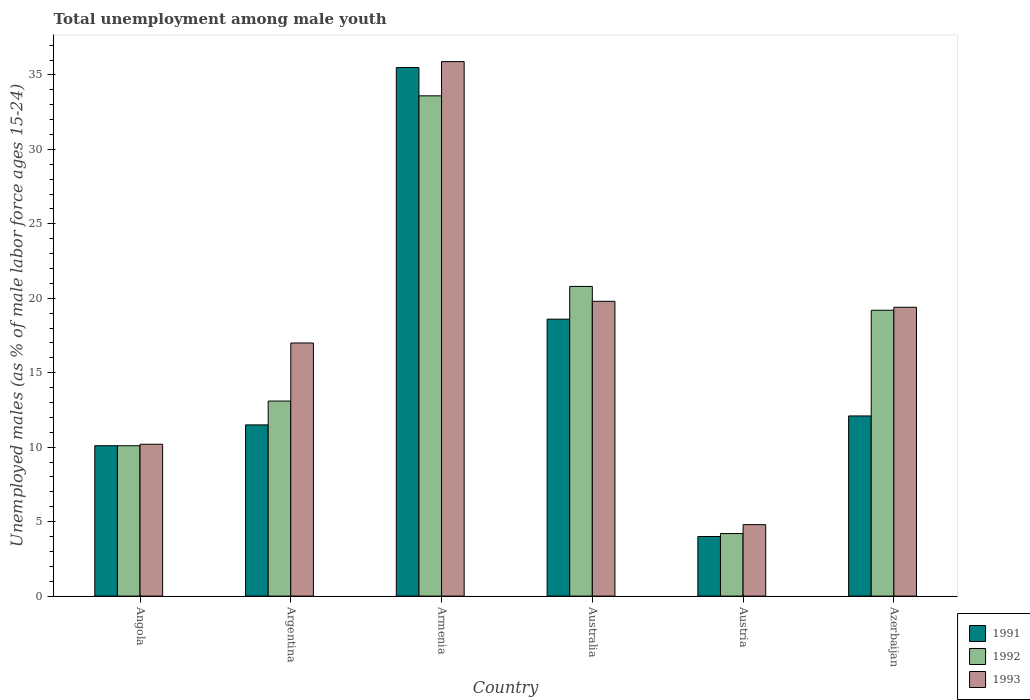How many groups of bars are there?
Offer a terse response. 6. How many bars are there on the 4th tick from the left?
Ensure brevity in your answer.  3. How many bars are there on the 1st tick from the right?
Make the answer very short. 3. In how many cases, is the number of bars for a given country not equal to the number of legend labels?
Keep it short and to the point. 0. What is the percentage of unemployed males in in 1992 in Azerbaijan?
Your response must be concise. 19.2. Across all countries, what is the maximum percentage of unemployed males in in 1992?
Make the answer very short. 33.6. Across all countries, what is the minimum percentage of unemployed males in in 1992?
Provide a succinct answer. 4.2. In which country was the percentage of unemployed males in in 1991 maximum?
Offer a very short reply. Armenia. What is the total percentage of unemployed males in in 1991 in the graph?
Make the answer very short. 91.8. What is the difference between the percentage of unemployed males in in 1993 in Angola and that in Argentina?
Your response must be concise. -6.8. What is the difference between the percentage of unemployed males in in 1993 in Austria and the percentage of unemployed males in in 1991 in Azerbaijan?
Offer a terse response. -7.3. What is the average percentage of unemployed males in in 1993 per country?
Your answer should be compact. 17.85. What is the difference between the percentage of unemployed males in of/in 1991 and percentage of unemployed males in of/in 1993 in Azerbaijan?
Your answer should be very brief. -7.3. In how many countries, is the percentage of unemployed males in in 1993 greater than 30 %?
Your response must be concise. 1. What is the ratio of the percentage of unemployed males in in 1993 in Armenia to that in Australia?
Keep it short and to the point. 1.81. Is the percentage of unemployed males in in 1991 in Angola less than that in Argentina?
Ensure brevity in your answer.  Yes. Is the difference between the percentage of unemployed males in in 1991 in Australia and Austria greater than the difference between the percentage of unemployed males in in 1993 in Australia and Austria?
Keep it short and to the point. No. What is the difference between the highest and the second highest percentage of unemployed males in in 1992?
Your answer should be very brief. 14.4. What is the difference between the highest and the lowest percentage of unemployed males in in 1991?
Your answer should be compact. 31.5. Is the sum of the percentage of unemployed males in in 1991 in Angola and Austria greater than the maximum percentage of unemployed males in in 1992 across all countries?
Give a very brief answer. No. What does the 1st bar from the left in Argentina represents?
Keep it short and to the point. 1991. What does the 3rd bar from the right in Australia represents?
Offer a very short reply. 1991. Is it the case that in every country, the sum of the percentage of unemployed males in in 1993 and percentage of unemployed males in in 1992 is greater than the percentage of unemployed males in in 1991?
Your response must be concise. Yes. What is the difference between two consecutive major ticks on the Y-axis?
Make the answer very short. 5. Are the values on the major ticks of Y-axis written in scientific E-notation?
Offer a terse response. No. Does the graph contain any zero values?
Provide a short and direct response. No. Where does the legend appear in the graph?
Give a very brief answer. Bottom right. How many legend labels are there?
Keep it short and to the point. 3. How are the legend labels stacked?
Provide a short and direct response. Vertical. What is the title of the graph?
Provide a succinct answer. Total unemployment among male youth. Does "1981" appear as one of the legend labels in the graph?
Your answer should be very brief. No. What is the label or title of the X-axis?
Offer a terse response. Country. What is the label or title of the Y-axis?
Give a very brief answer. Unemployed males (as % of male labor force ages 15-24). What is the Unemployed males (as % of male labor force ages 15-24) of 1991 in Angola?
Keep it short and to the point. 10.1. What is the Unemployed males (as % of male labor force ages 15-24) of 1992 in Angola?
Ensure brevity in your answer.  10.1. What is the Unemployed males (as % of male labor force ages 15-24) of 1993 in Angola?
Provide a short and direct response. 10.2. What is the Unemployed males (as % of male labor force ages 15-24) of 1991 in Argentina?
Ensure brevity in your answer.  11.5. What is the Unemployed males (as % of male labor force ages 15-24) of 1992 in Argentina?
Keep it short and to the point. 13.1. What is the Unemployed males (as % of male labor force ages 15-24) of 1991 in Armenia?
Offer a terse response. 35.5. What is the Unemployed males (as % of male labor force ages 15-24) of 1992 in Armenia?
Keep it short and to the point. 33.6. What is the Unemployed males (as % of male labor force ages 15-24) of 1993 in Armenia?
Keep it short and to the point. 35.9. What is the Unemployed males (as % of male labor force ages 15-24) in 1991 in Australia?
Make the answer very short. 18.6. What is the Unemployed males (as % of male labor force ages 15-24) of 1992 in Australia?
Your answer should be compact. 20.8. What is the Unemployed males (as % of male labor force ages 15-24) of 1993 in Australia?
Your response must be concise. 19.8. What is the Unemployed males (as % of male labor force ages 15-24) of 1992 in Austria?
Make the answer very short. 4.2. What is the Unemployed males (as % of male labor force ages 15-24) of 1993 in Austria?
Your answer should be compact. 4.8. What is the Unemployed males (as % of male labor force ages 15-24) in 1991 in Azerbaijan?
Your response must be concise. 12.1. What is the Unemployed males (as % of male labor force ages 15-24) of 1992 in Azerbaijan?
Keep it short and to the point. 19.2. What is the Unemployed males (as % of male labor force ages 15-24) of 1993 in Azerbaijan?
Make the answer very short. 19.4. Across all countries, what is the maximum Unemployed males (as % of male labor force ages 15-24) of 1991?
Offer a terse response. 35.5. Across all countries, what is the maximum Unemployed males (as % of male labor force ages 15-24) in 1992?
Give a very brief answer. 33.6. Across all countries, what is the maximum Unemployed males (as % of male labor force ages 15-24) of 1993?
Keep it short and to the point. 35.9. Across all countries, what is the minimum Unemployed males (as % of male labor force ages 15-24) of 1992?
Provide a succinct answer. 4.2. Across all countries, what is the minimum Unemployed males (as % of male labor force ages 15-24) in 1993?
Ensure brevity in your answer.  4.8. What is the total Unemployed males (as % of male labor force ages 15-24) in 1991 in the graph?
Give a very brief answer. 91.8. What is the total Unemployed males (as % of male labor force ages 15-24) of 1992 in the graph?
Offer a terse response. 101. What is the total Unemployed males (as % of male labor force ages 15-24) in 1993 in the graph?
Provide a short and direct response. 107.1. What is the difference between the Unemployed males (as % of male labor force ages 15-24) in 1991 in Angola and that in Armenia?
Offer a terse response. -25.4. What is the difference between the Unemployed males (as % of male labor force ages 15-24) in 1992 in Angola and that in Armenia?
Make the answer very short. -23.5. What is the difference between the Unemployed males (as % of male labor force ages 15-24) in 1993 in Angola and that in Armenia?
Ensure brevity in your answer.  -25.7. What is the difference between the Unemployed males (as % of male labor force ages 15-24) in 1991 in Angola and that in Australia?
Ensure brevity in your answer.  -8.5. What is the difference between the Unemployed males (as % of male labor force ages 15-24) of 1992 in Angola and that in Australia?
Give a very brief answer. -10.7. What is the difference between the Unemployed males (as % of male labor force ages 15-24) of 1993 in Angola and that in Australia?
Offer a terse response. -9.6. What is the difference between the Unemployed males (as % of male labor force ages 15-24) in 1991 in Angola and that in Austria?
Ensure brevity in your answer.  6.1. What is the difference between the Unemployed males (as % of male labor force ages 15-24) in 1992 in Angola and that in Azerbaijan?
Give a very brief answer. -9.1. What is the difference between the Unemployed males (as % of male labor force ages 15-24) of 1991 in Argentina and that in Armenia?
Keep it short and to the point. -24. What is the difference between the Unemployed males (as % of male labor force ages 15-24) of 1992 in Argentina and that in Armenia?
Keep it short and to the point. -20.5. What is the difference between the Unemployed males (as % of male labor force ages 15-24) of 1993 in Argentina and that in Armenia?
Ensure brevity in your answer.  -18.9. What is the difference between the Unemployed males (as % of male labor force ages 15-24) of 1991 in Argentina and that in Australia?
Make the answer very short. -7.1. What is the difference between the Unemployed males (as % of male labor force ages 15-24) of 1993 in Argentina and that in Australia?
Your answer should be very brief. -2.8. What is the difference between the Unemployed males (as % of male labor force ages 15-24) in 1991 in Argentina and that in Austria?
Give a very brief answer. 7.5. What is the difference between the Unemployed males (as % of male labor force ages 15-24) of 1992 in Argentina and that in Austria?
Ensure brevity in your answer.  8.9. What is the difference between the Unemployed males (as % of male labor force ages 15-24) of 1993 in Argentina and that in Austria?
Provide a succinct answer. 12.2. What is the difference between the Unemployed males (as % of male labor force ages 15-24) of 1993 in Argentina and that in Azerbaijan?
Give a very brief answer. -2.4. What is the difference between the Unemployed males (as % of male labor force ages 15-24) in 1991 in Armenia and that in Australia?
Your answer should be compact. 16.9. What is the difference between the Unemployed males (as % of male labor force ages 15-24) of 1992 in Armenia and that in Australia?
Your answer should be compact. 12.8. What is the difference between the Unemployed males (as % of male labor force ages 15-24) in 1993 in Armenia and that in Australia?
Provide a succinct answer. 16.1. What is the difference between the Unemployed males (as % of male labor force ages 15-24) in 1991 in Armenia and that in Austria?
Provide a succinct answer. 31.5. What is the difference between the Unemployed males (as % of male labor force ages 15-24) of 1992 in Armenia and that in Austria?
Offer a very short reply. 29.4. What is the difference between the Unemployed males (as % of male labor force ages 15-24) in 1993 in Armenia and that in Austria?
Give a very brief answer. 31.1. What is the difference between the Unemployed males (as % of male labor force ages 15-24) in 1991 in Armenia and that in Azerbaijan?
Make the answer very short. 23.4. What is the difference between the Unemployed males (as % of male labor force ages 15-24) in 1992 in Armenia and that in Azerbaijan?
Your response must be concise. 14.4. What is the difference between the Unemployed males (as % of male labor force ages 15-24) in 1991 in Australia and that in Austria?
Keep it short and to the point. 14.6. What is the difference between the Unemployed males (as % of male labor force ages 15-24) in 1992 in Australia and that in Austria?
Your answer should be compact. 16.6. What is the difference between the Unemployed males (as % of male labor force ages 15-24) of 1993 in Australia and that in Austria?
Provide a short and direct response. 15. What is the difference between the Unemployed males (as % of male labor force ages 15-24) in 1991 in Australia and that in Azerbaijan?
Make the answer very short. 6.5. What is the difference between the Unemployed males (as % of male labor force ages 15-24) in 1992 in Australia and that in Azerbaijan?
Offer a very short reply. 1.6. What is the difference between the Unemployed males (as % of male labor force ages 15-24) in 1993 in Austria and that in Azerbaijan?
Your answer should be very brief. -14.6. What is the difference between the Unemployed males (as % of male labor force ages 15-24) in 1991 in Angola and the Unemployed males (as % of male labor force ages 15-24) in 1992 in Argentina?
Keep it short and to the point. -3. What is the difference between the Unemployed males (as % of male labor force ages 15-24) in 1991 in Angola and the Unemployed males (as % of male labor force ages 15-24) in 1993 in Argentina?
Offer a terse response. -6.9. What is the difference between the Unemployed males (as % of male labor force ages 15-24) of 1991 in Angola and the Unemployed males (as % of male labor force ages 15-24) of 1992 in Armenia?
Your answer should be compact. -23.5. What is the difference between the Unemployed males (as % of male labor force ages 15-24) of 1991 in Angola and the Unemployed males (as % of male labor force ages 15-24) of 1993 in Armenia?
Your answer should be very brief. -25.8. What is the difference between the Unemployed males (as % of male labor force ages 15-24) of 1992 in Angola and the Unemployed males (as % of male labor force ages 15-24) of 1993 in Armenia?
Make the answer very short. -25.8. What is the difference between the Unemployed males (as % of male labor force ages 15-24) of 1991 in Angola and the Unemployed males (as % of male labor force ages 15-24) of 1992 in Australia?
Your answer should be very brief. -10.7. What is the difference between the Unemployed males (as % of male labor force ages 15-24) in 1992 in Angola and the Unemployed males (as % of male labor force ages 15-24) in 1993 in Australia?
Ensure brevity in your answer.  -9.7. What is the difference between the Unemployed males (as % of male labor force ages 15-24) of 1991 in Angola and the Unemployed males (as % of male labor force ages 15-24) of 1993 in Austria?
Make the answer very short. 5.3. What is the difference between the Unemployed males (as % of male labor force ages 15-24) of 1992 in Angola and the Unemployed males (as % of male labor force ages 15-24) of 1993 in Austria?
Your answer should be compact. 5.3. What is the difference between the Unemployed males (as % of male labor force ages 15-24) of 1992 in Angola and the Unemployed males (as % of male labor force ages 15-24) of 1993 in Azerbaijan?
Offer a very short reply. -9.3. What is the difference between the Unemployed males (as % of male labor force ages 15-24) of 1991 in Argentina and the Unemployed males (as % of male labor force ages 15-24) of 1992 in Armenia?
Provide a short and direct response. -22.1. What is the difference between the Unemployed males (as % of male labor force ages 15-24) in 1991 in Argentina and the Unemployed males (as % of male labor force ages 15-24) in 1993 in Armenia?
Provide a succinct answer. -24.4. What is the difference between the Unemployed males (as % of male labor force ages 15-24) of 1992 in Argentina and the Unemployed males (as % of male labor force ages 15-24) of 1993 in Armenia?
Ensure brevity in your answer.  -22.8. What is the difference between the Unemployed males (as % of male labor force ages 15-24) in 1992 in Argentina and the Unemployed males (as % of male labor force ages 15-24) in 1993 in Australia?
Keep it short and to the point. -6.7. What is the difference between the Unemployed males (as % of male labor force ages 15-24) of 1991 in Argentina and the Unemployed males (as % of male labor force ages 15-24) of 1992 in Azerbaijan?
Keep it short and to the point. -7.7. What is the difference between the Unemployed males (as % of male labor force ages 15-24) in 1991 in Armenia and the Unemployed males (as % of male labor force ages 15-24) in 1992 in Australia?
Your answer should be compact. 14.7. What is the difference between the Unemployed males (as % of male labor force ages 15-24) in 1991 in Armenia and the Unemployed males (as % of male labor force ages 15-24) in 1993 in Australia?
Your answer should be compact. 15.7. What is the difference between the Unemployed males (as % of male labor force ages 15-24) in 1992 in Armenia and the Unemployed males (as % of male labor force ages 15-24) in 1993 in Australia?
Offer a terse response. 13.8. What is the difference between the Unemployed males (as % of male labor force ages 15-24) of 1991 in Armenia and the Unemployed males (as % of male labor force ages 15-24) of 1992 in Austria?
Offer a very short reply. 31.3. What is the difference between the Unemployed males (as % of male labor force ages 15-24) in 1991 in Armenia and the Unemployed males (as % of male labor force ages 15-24) in 1993 in Austria?
Provide a succinct answer. 30.7. What is the difference between the Unemployed males (as % of male labor force ages 15-24) of 1992 in Armenia and the Unemployed males (as % of male labor force ages 15-24) of 1993 in Austria?
Your answer should be very brief. 28.8. What is the difference between the Unemployed males (as % of male labor force ages 15-24) of 1991 in Armenia and the Unemployed males (as % of male labor force ages 15-24) of 1993 in Azerbaijan?
Your answer should be very brief. 16.1. What is the difference between the Unemployed males (as % of male labor force ages 15-24) of 1992 in Armenia and the Unemployed males (as % of male labor force ages 15-24) of 1993 in Azerbaijan?
Ensure brevity in your answer.  14.2. What is the difference between the Unemployed males (as % of male labor force ages 15-24) in 1991 in Australia and the Unemployed males (as % of male labor force ages 15-24) in 1992 in Austria?
Your response must be concise. 14.4. What is the difference between the Unemployed males (as % of male labor force ages 15-24) of 1991 in Australia and the Unemployed males (as % of male labor force ages 15-24) of 1993 in Austria?
Your response must be concise. 13.8. What is the difference between the Unemployed males (as % of male labor force ages 15-24) of 1991 in Australia and the Unemployed males (as % of male labor force ages 15-24) of 1992 in Azerbaijan?
Make the answer very short. -0.6. What is the difference between the Unemployed males (as % of male labor force ages 15-24) in 1992 in Australia and the Unemployed males (as % of male labor force ages 15-24) in 1993 in Azerbaijan?
Provide a short and direct response. 1.4. What is the difference between the Unemployed males (as % of male labor force ages 15-24) in 1991 in Austria and the Unemployed males (as % of male labor force ages 15-24) in 1992 in Azerbaijan?
Your response must be concise. -15.2. What is the difference between the Unemployed males (as % of male labor force ages 15-24) of 1991 in Austria and the Unemployed males (as % of male labor force ages 15-24) of 1993 in Azerbaijan?
Ensure brevity in your answer.  -15.4. What is the difference between the Unemployed males (as % of male labor force ages 15-24) in 1992 in Austria and the Unemployed males (as % of male labor force ages 15-24) in 1993 in Azerbaijan?
Give a very brief answer. -15.2. What is the average Unemployed males (as % of male labor force ages 15-24) in 1991 per country?
Offer a very short reply. 15.3. What is the average Unemployed males (as % of male labor force ages 15-24) of 1992 per country?
Offer a terse response. 16.83. What is the average Unemployed males (as % of male labor force ages 15-24) in 1993 per country?
Offer a very short reply. 17.85. What is the difference between the Unemployed males (as % of male labor force ages 15-24) of 1991 and Unemployed males (as % of male labor force ages 15-24) of 1992 in Angola?
Your answer should be compact. 0. What is the difference between the Unemployed males (as % of male labor force ages 15-24) of 1992 and Unemployed males (as % of male labor force ages 15-24) of 1993 in Angola?
Your answer should be compact. -0.1. What is the difference between the Unemployed males (as % of male labor force ages 15-24) of 1991 and Unemployed males (as % of male labor force ages 15-24) of 1992 in Argentina?
Your answer should be compact. -1.6. What is the difference between the Unemployed males (as % of male labor force ages 15-24) of 1992 and Unemployed males (as % of male labor force ages 15-24) of 1993 in Argentina?
Your answer should be very brief. -3.9. What is the difference between the Unemployed males (as % of male labor force ages 15-24) of 1991 and Unemployed males (as % of male labor force ages 15-24) of 1992 in Armenia?
Keep it short and to the point. 1.9. What is the difference between the Unemployed males (as % of male labor force ages 15-24) of 1991 and Unemployed males (as % of male labor force ages 15-24) of 1993 in Armenia?
Keep it short and to the point. -0.4. What is the difference between the Unemployed males (as % of male labor force ages 15-24) in 1992 and Unemployed males (as % of male labor force ages 15-24) in 1993 in Australia?
Provide a short and direct response. 1. What is the difference between the Unemployed males (as % of male labor force ages 15-24) of 1991 and Unemployed males (as % of male labor force ages 15-24) of 1992 in Austria?
Make the answer very short. -0.2. What is the difference between the Unemployed males (as % of male labor force ages 15-24) in 1991 and Unemployed males (as % of male labor force ages 15-24) in 1993 in Austria?
Ensure brevity in your answer.  -0.8. What is the difference between the Unemployed males (as % of male labor force ages 15-24) of 1992 and Unemployed males (as % of male labor force ages 15-24) of 1993 in Azerbaijan?
Your answer should be compact. -0.2. What is the ratio of the Unemployed males (as % of male labor force ages 15-24) of 1991 in Angola to that in Argentina?
Your answer should be compact. 0.88. What is the ratio of the Unemployed males (as % of male labor force ages 15-24) in 1992 in Angola to that in Argentina?
Give a very brief answer. 0.77. What is the ratio of the Unemployed males (as % of male labor force ages 15-24) in 1991 in Angola to that in Armenia?
Your response must be concise. 0.28. What is the ratio of the Unemployed males (as % of male labor force ages 15-24) in 1992 in Angola to that in Armenia?
Your response must be concise. 0.3. What is the ratio of the Unemployed males (as % of male labor force ages 15-24) of 1993 in Angola to that in Armenia?
Make the answer very short. 0.28. What is the ratio of the Unemployed males (as % of male labor force ages 15-24) in 1991 in Angola to that in Australia?
Give a very brief answer. 0.54. What is the ratio of the Unemployed males (as % of male labor force ages 15-24) of 1992 in Angola to that in Australia?
Your response must be concise. 0.49. What is the ratio of the Unemployed males (as % of male labor force ages 15-24) in 1993 in Angola to that in Australia?
Ensure brevity in your answer.  0.52. What is the ratio of the Unemployed males (as % of male labor force ages 15-24) in 1991 in Angola to that in Austria?
Give a very brief answer. 2.52. What is the ratio of the Unemployed males (as % of male labor force ages 15-24) of 1992 in Angola to that in Austria?
Offer a very short reply. 2.4. What is the ratio of the Unemployed males (as % of male labor force ages 15-24) of 1993 in Angola to that in Austria?
Your response must be concise. 2.12. What is the ratio of the Unemployed males (as % of male labor force ages 15-24) in 1991 in Angola to that in Azerbaijan?
Your answer should be very brief. 0.83. What is the ratio of the Unemployed males (as % of male labor force ages 15-24) of 1992 in Angola to that in Azerbaijan?
Offer a very short reply. 0.53. What is the ratio of the Unemployed males (as % of male labor force ages 15-24) in 1993 in Angola to that in Azerbaijan?
Ensure brevity in your answer.  0.53. What is the ratio of the Unemployed males (as % of male labor force ages 15-24) in 1991 in Argentina to that in Armenia?
Make the answer very short. 0.32. What is the ratio of the Unemployed males (as % of male labor force ages 15-24) of 1992 in Argentina to that in Armenia?
Make the answer very short. 0.39. What is the ratio of the Unemployed males (as % of male labor force ages 15-24) of 1993 in Argentina to that in Armenia?
Ensure brevity in your answer.  0.47. What is the ratio of the Unemployed males (as % of male labor force ages 15-24) of 1991 in Argentina to that in Australia?
Your response must be concise. 0.62. What is the ratio of the Unemployed males (as % of male labor force ages 15-24) in 1992 in Argentina to that in Australia?
Keep it short and to the point. 0.63. What is the ratio of the Unemployed males (as % of male labor force ages 15-24) of 1993 in Argentina to that in Australia?
Provide a short and direct response. 0.86. What is the ratio of the Unemployed males (as % of male labor force ages 15-24) in 1991 in Argentina to that in Austria?
Provide a short and direct response. 2.88. What is the ratio of the Unemployed males (as % of male labor force ages 15-24) in 1992 in Argentina to that in Austria?
Your answer should be very brief. 3.12. What is the ratio of the Unemployed males (as % of male labor force ages 15-24) in 1993 in Argentina to that in Austria?
Offer a very short reply. 3.54. What is the ratio of the Unemployed males (as % of male labor force ages 15-24) of 1991 in Argentina to that in Azerbaijan?
Your response must be concise. 0.95. What is the ratio of the Unemployed males (as % of male labor force ages 15-24) in 1992 in Argentina to that in Azerbaijan?
Provide a succinct answer. 0.68. What is the ratio of the Unemployed males (as % of male labor force ages 15-24) of 1993 in Argentina to that in Azerbaijan?
Offer a very short reply. 0.88. What is the ratio of the Unemployed males (as % of male labor force ages 15-24) in 1991 in Armenia to that in Australia?
Your answer should be very brief. 1.91. What is the ratio of the Unemployed males (as % of male labor force ages 15-24) of 1992 in Armenia to that in Australia?
Your response must be concise. 1.62. What is the ratio of the Unemployed males (as % of male labor force ages 15-24) of 1993 in Armenia to that in Australia?
Your response must be concise. 1.81. What is the ratio of the Unemployed males (as % of male labor force ages 15-24) of 1991 in Armenia to that in Austria?
Keep it short and to the point. 8.88. What is the ratio of the Unemployed males (as % of male labor force ages 15-24) in 1992 in Armenia to that in Austria?
Provide a short and direct response. 8. What is the ratio of the Unemployed males (as % of male labor force ages 15-24) of 1993 in Armenia to that in Austria?
Your answer should be very brief. 7.48. What is the ratio of the Unemployed males (as % of male labor force ages 15-24) of 1991 in Armenia to that in Azerbaijan?
Provide a succinct answer. 2.93. What is the ratio of the Unemployed males (as % of male labor force ages 15-24) in 1992 in Armenia to that in Azerbaijan?
Make the answer very short. 1.75. What is the ratio of the Unemployed males (as % of male labor force ages 15-24) of 1993 in Armenia to that in Azerbaijan?
Offer a terse response. 1.85. What is the ratio of the Unemployed males (as % of male labor force ages 15-24) of 1991 in Australia to that in Austria?
Keep it short and to the point. 4.65. What is the ratio of the Unemployed males (as % of male labor force ages 15-24) of 1992 in Australia to that in Austria?
Ensure brevity in your answer.  4.95. What is the ratio of the Unemployed males (as % of male labor force ages 15-24) in 1993 in Australia to that in Austria?
Provide a succinct answer. 4.12. What is the ratio of the Unemployed males (as % of male labor force ages 15-24) in 1991 in Australia to that in Azerbaijan?
Offer a very short reply. 1.54. What is the ratio of the Unemployed males (as % of male labor force ages 15-24) of 1993 in Australia to that in Azerbaijan?
Offer a very short reply. 1.02. What is the ratio of the Unemployed males (as % of male labor force ages 15-24) of 1991 in Austria to that in Azerbaijan?
Your answer should be very brief. 0.33. What is the ratio of the Unemployed males (as % of male labor force ages 15-24) in 1992 in Austria to that in Azerbaijan?
Ensure brevity in your answer.  0.22. What is the ratio of the Unemployed males (as % of male labor force ages 15-24) of 1993 in Austria to that in Azerbaijan?
Your answer should be compact. 0.25. What is the difference between the highest and the second highest Unemployed males (as % of male labor force ages 15-24) in 1991?
Your response must be concise. 16.9. What is the difference between the highest and the second highest Unemployed males (as % of male labor force ages 15-24) of 1992?
Your answer should be very brief. 12.8. What is the difference between the highest and the lowest Unemployed males (as % of male labor force ages 15-24) of 1991?
Keep it short and to the point. 31.5. What is the difference between the highest and the lowest Unemployed males (as % of male labor force ages 15-24) in 1992?
Provide a short and direct response. 29.4. What is the difference between the highest and the lowest Unemployed males (as % of male labor force ages 15-24) of 1993?
Your answer should be compact. 31.1. 